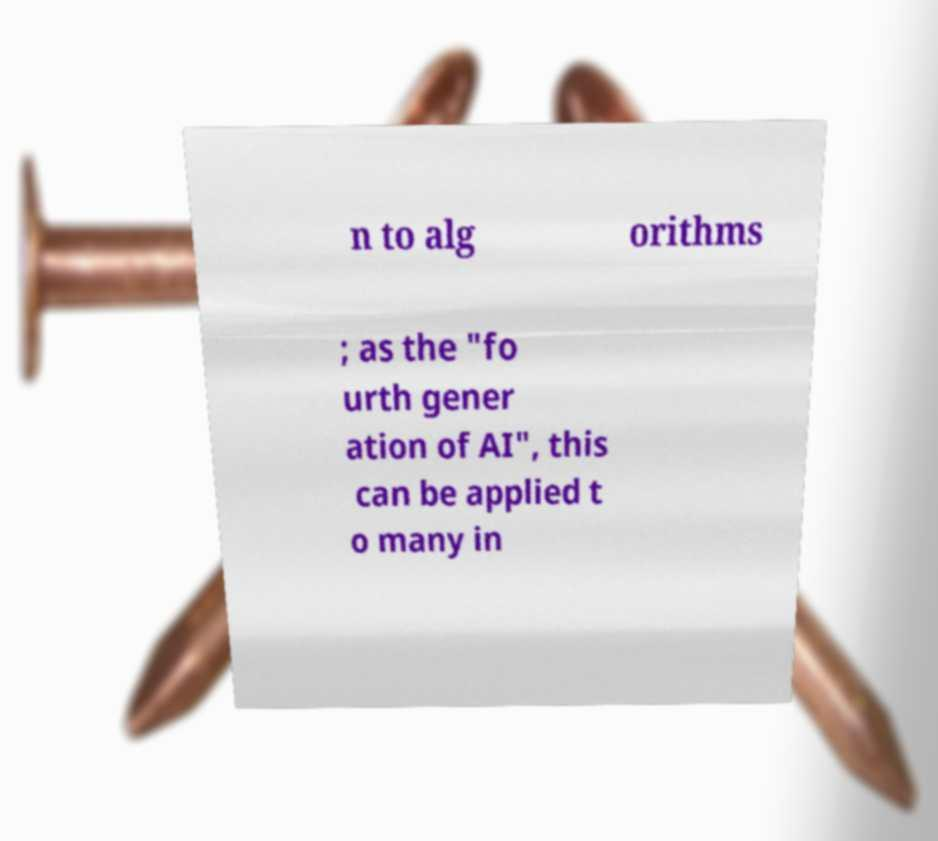What messages or text are displayed in this image? I need them in a readable, typed format. n to alg orithms ; as the "fo urth gener ation of AI", this can be applied t o many in 